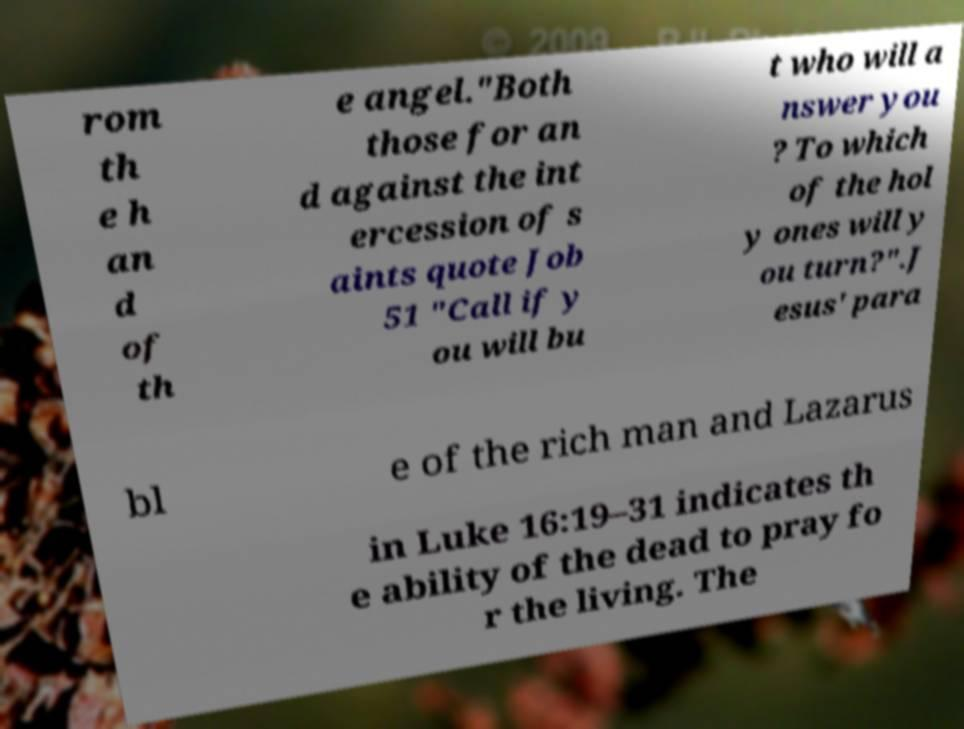I need the written content from this picture converted into text. Can you do that? rom th e h an d of th e angel."Both those for an d against the int ercession of s aints quote Job 51 "Call if y ou will bu t who will a nswer you ? To which of the hol y ones will y ou turn?".J esus' para bl e of the rich man and Lazarus in Luke 16:19–31 indicates th e ability of the dead to pray fo r the living. The 